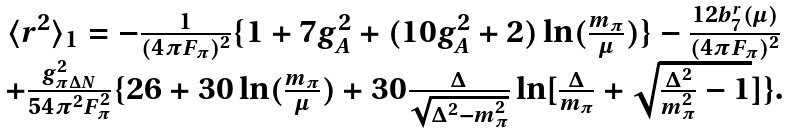<formula> <loc_0><loc_0><loc_500><loc_500>\begin{array} [ c ] { c } \langle r ^ { 2 } \rangle _ { 1 } = - \frac { 1 } { ( 4 \pi F _ { \pi } ) ^ { 2 } } \{ 1 + 7 g _ { A } ^ { 2 } + ( 1 0 g _ { A } ^ { 2 } + 2 ) \ln ( \frac { m _ { \pi } } { \mu } ) \} - \frac { 1 2 b _ { 7 } ^ { r } ( \mu ) } { ( 4 \pi F _ { \pi } ) ^ { 2 } } \\ + \frac { g _ { \pi \Delta N } ^ { 2 } } { 5 4 \pi ^ { 2 } F _ { \pi } ^ { 2 } } \{ 2 6 + 3 0 \ln ( \frac { m _ { \pi } } { \mu } ) + 3 0 \frac { \Delta } { \sqrt { \Delta ^ { 2 } - m _ { \pi } ^ { 2 } } } \ln [ \frac { \Delta } { m _ { \pi } } + \sqrt { \frac { \Delta ^ { 2 } } { m _ { \pi } ^ { 2 } } - 1 } ] \} . \end{array}</formula> 